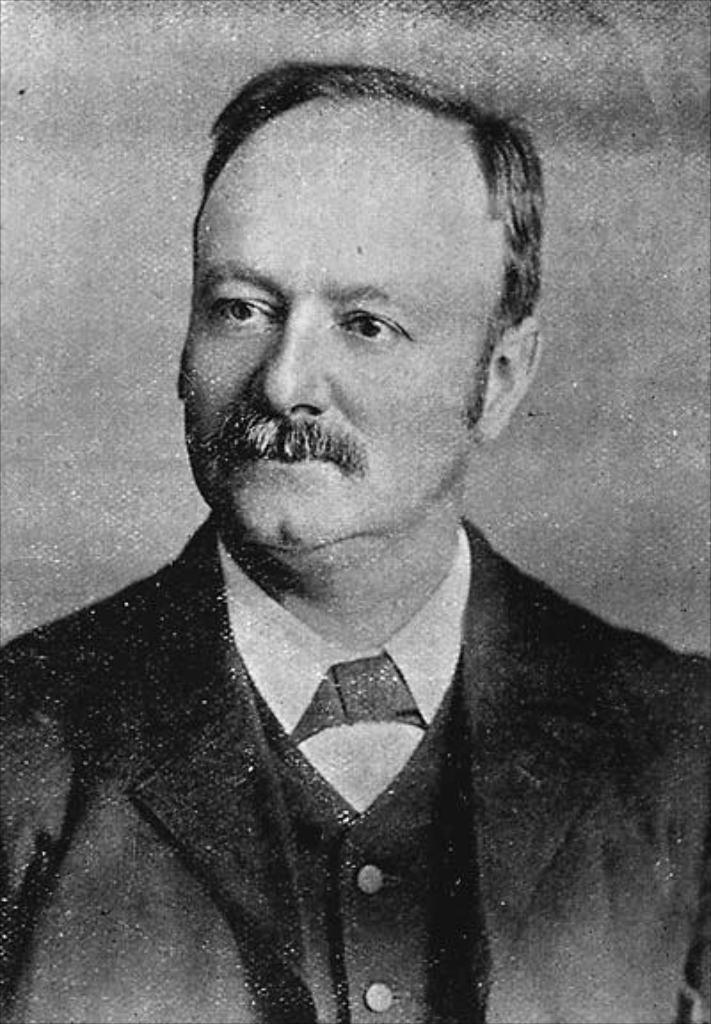Describe this image in one or two sentences. In this image I can see picture of a man. I can see this image is black and white in color. 